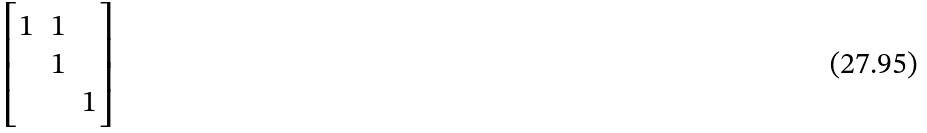Convert formula to latex. <formula><loc_0><loc_0><loc_500><loc_500>\begin{bmatrix} 1 & 1 \\ & 1 \\ & & 1 \end{bmatrix}</formula> 